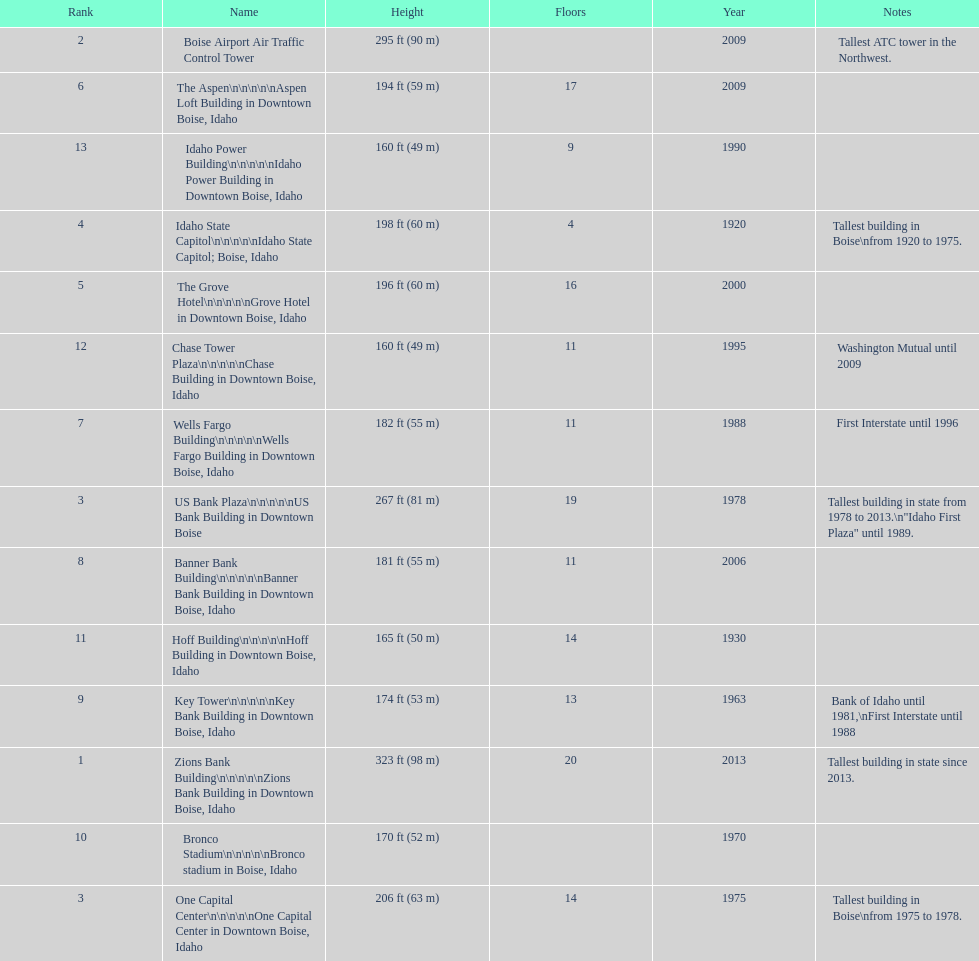What is the name of the last building on this chart? Idaho Power Building. 